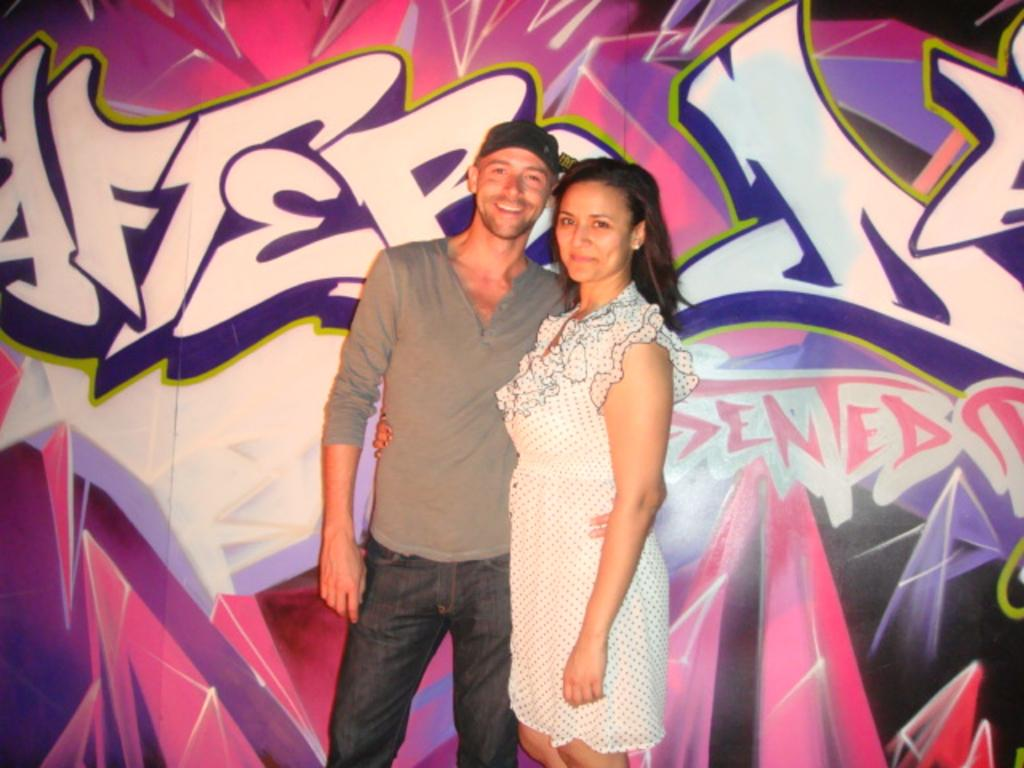How many people are in the image? There are two people standing in the image. What are the people doing in the image? The people are posing for a picture. What can be seen in the background of the image? There is graffiti on a wall in the background of the image. What type of glass can be seen in the image? There is no glass present in the image. What historical event is depicted in the graffiti in the image? The image does not provide enough information to determine any historical event depicted in the graffiti. 